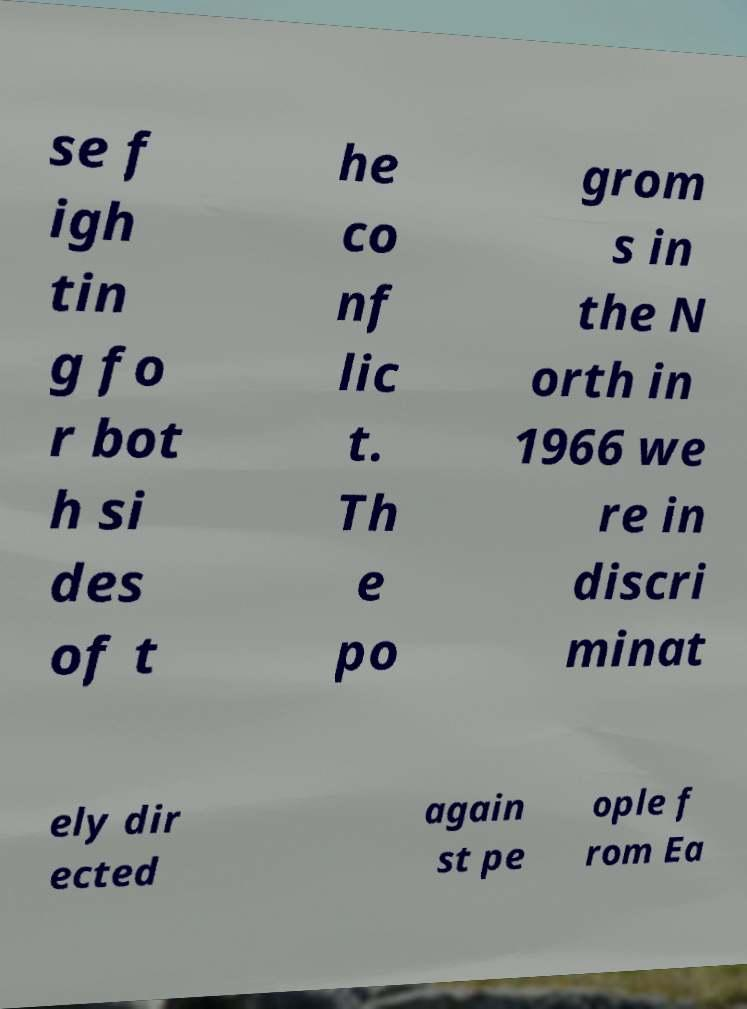What messages or text are displayed in this image? I need them in a readable, typed format. se f igh tin g fo r bot h si des of t he co nf lic t. Th e po grom s in the N orth in 1966 we re in discri minat ely dir ected again st pe ople f rom Ea 